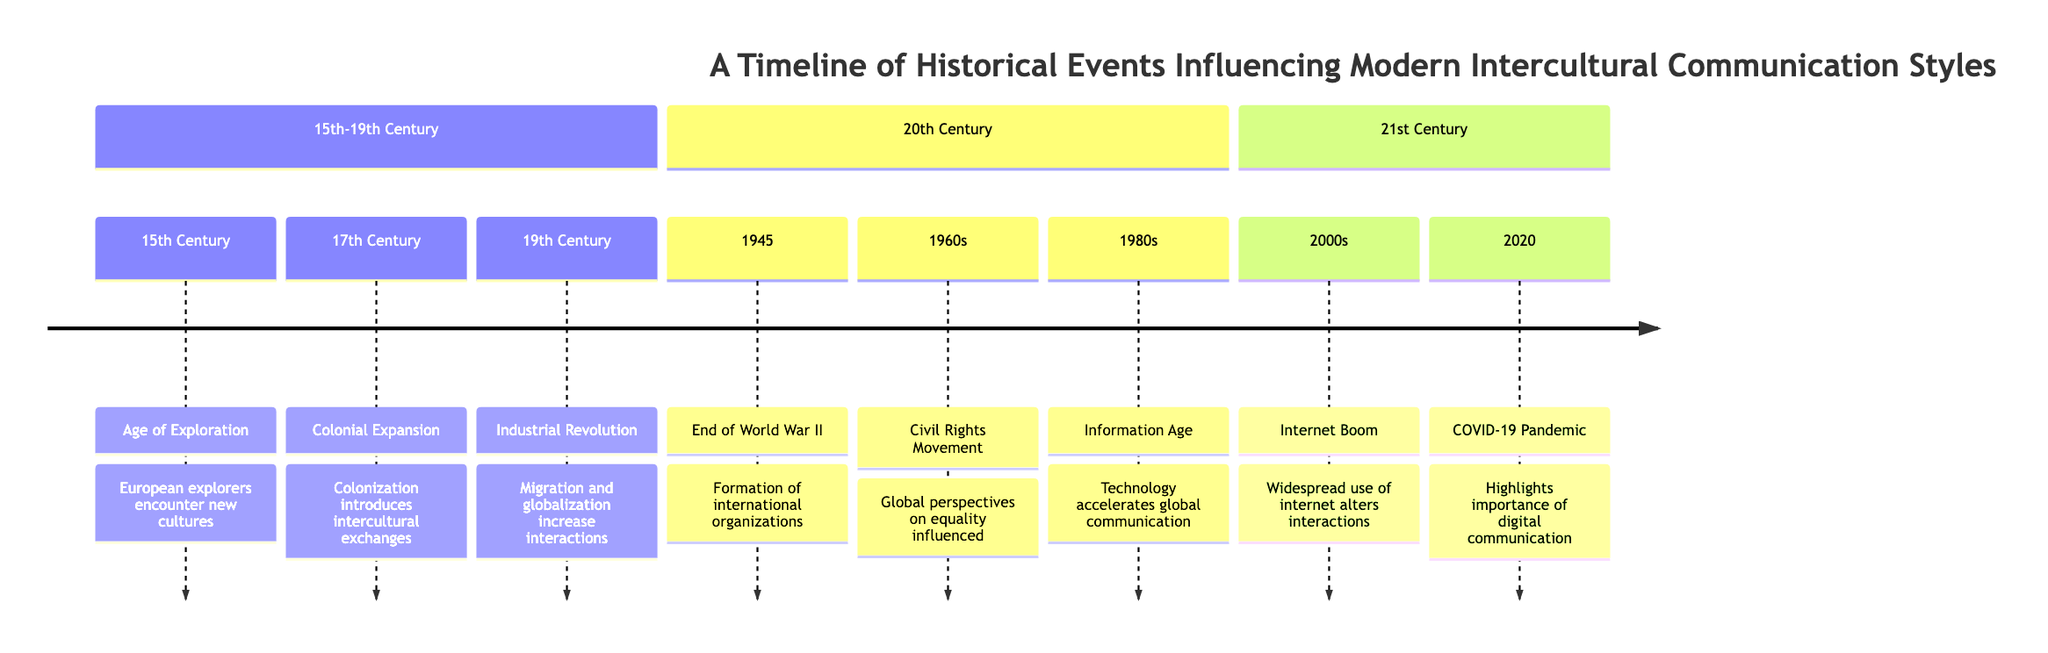What significant event occurred in the 19th Century? According to the diagram, the significant event in the 19th Century is the Industrial Revolution, which is explicitly stated in the timeline along with its influence on migration and globalization.
Answer: Industrial Revolution What was introduced during the 17th Century? The diagram indicates that colonization is the noteworthy development in the 17th Century, highlighting the introduction of intercultural exchanges during this period.
Answer: Colonial Expansion How many major sections are there in this timeline? By examining the timeline, we see there are three distinct sections: 15th-19th Century, 20th Century, and 21st Century. This can be easily counted by observing the section headers.
Answer: 3 Which event corresponds with the formation of international organizations? The diagram shows that the event corresponding with the formation of international organizations is the end of World War II in 1945. This connection is clearly indicated in the timeline.
Answer: End of World War II What technological advancement influenced communication in the 1980s? The timeline states that during the 1980s, the Information Age emerged, which refers to the technological advancements that accelerated global communication. This is a clear cause and effect as presented in the diagram.
Answer: Information Age Why is the COVID-19 Pandemic significant in the context of this timeline? The timeline specifically notes that the COVID-19 Pandemic in 2020 highlighted the importance of digital communication, suggesting a shift in interaction styles due to the pandemic's impact. This relationship is clear in the section detailing the 21st Century.
Answer: Importance of digital communication Which event marked a global perspective on equality? As noted in the diagram, the Civil Rights Movement in the 1960s is specifically associated with influencing global perspectives on equality, demonstrating its importance in shaping intercultural communication.
Answer: Civil Rights Movement What cultural phenomenon began widely in the 2000s? The timeline indicates that the Internet Boom occurred in the 2000s, marking a significant shift in how interactions were conducted through widespread internet use. This is directly stated in the 21st Century section of the timeline.
Answer: Internet Boom What effect did the Industrial Revolution have on interactions? According to the diagram, the Industrial Revolution increased interactions due to migration and globalization, connecting multiple historical data points that show its significance in intercultural communication.
Answer: Migration and globalization 